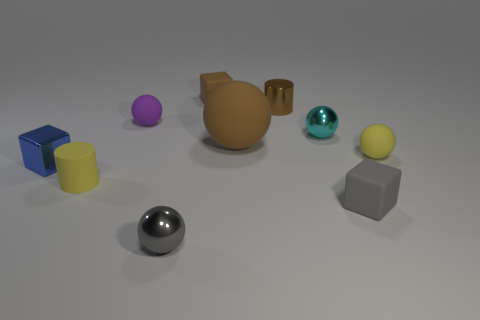Is the material of the tiny cylinder in front of the tiny cyan sphere the same as the yellow ball?
Your answer should be very brief. Yes. There is a purple thing; what shape is it?
Make the answer very short. Sphere. Is the number of large balls in front of the yellow cylinder greater than the number of big gray things?
Offer a terse response. No. Is there any other thing that is the same shape as the big thing?
Offer a terse response. Yes. The rubber thing that is the same shape as the brown shiny thing is what color?
Keep it short and to the point. Yellow. What is the shape of the small gray metallic thing on the left side of the brown ball?
Offer a very short reply. Sphere. Are there any small metallic objects on the right side of the blue metallic object?
Provide a short and direct response. Yes. Are there any other things that have the same size as the yellow sphere?
Make the answer very short. Yes. The cylinder that is the same material as the tiny blue block is what color?
Your answer should be very brief. Brown. There is a tiny cylinder that is left of the large thing; does it have the same color as the small matte cube in front of the small yellow rubber sphere?
Provide a short and direct response. No. 